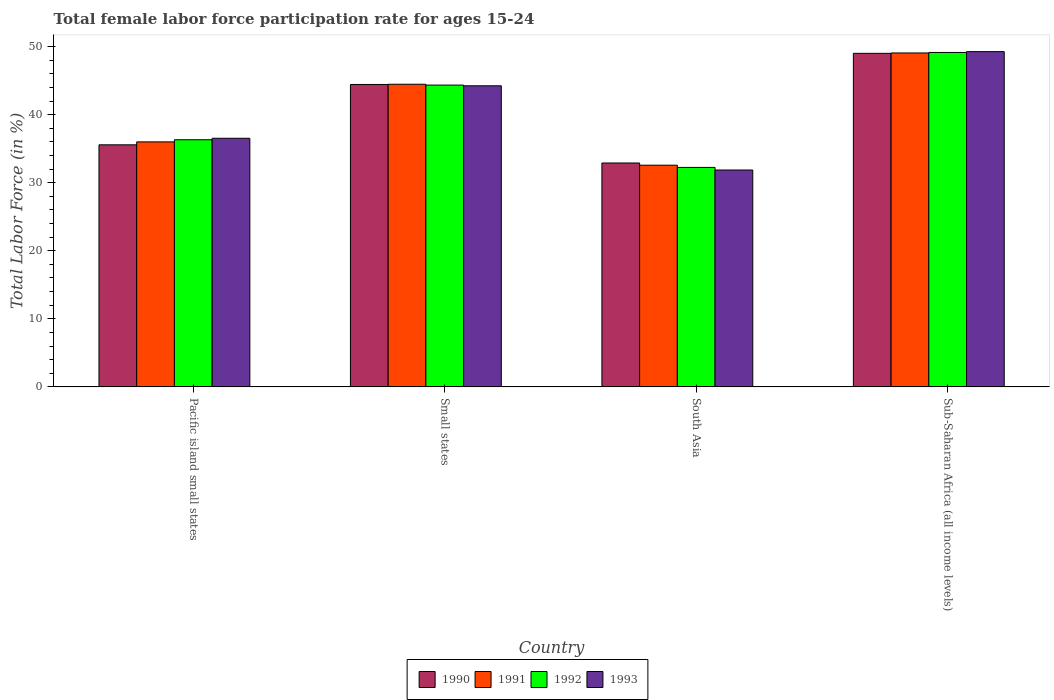Are the number of bars on each tick of the X-axis equal?
Your answer should be very brief. Yes. What is the label of the 1st group of bars from the left?
Your response must be concise. Pacific island small states. In how many cases, is the number of bars for a given country not equal to the number of legend labels?
Keep it short and to the point. 0. What is the female labor force participation rate in 1992 in South Asia?
Your answer should be very brief. 32.24. Across all countries, what is the maximum female labor force participation rate in 1993?
Give a very brief answer. 49.25. Across all countries, what is the minimum female labor force participation rate in 1992?
Give a very brief answer. 32.24. In which country was the female labor force participation rate in 1990 maximum?
Offer a terse response. Sub-Saharan Africa (all income levels). What is the total female labor force participation rate in 1993 in the graph?
Your answer should be very brief. 161.87. What is the difference between the female labor force participation rate in 1993 in Pacific island small states and that in Sub-Saharan Africa (all income levels)?
Offer a very short reply. -12.73. What is the difference between the female labor force participation rate in 1991 in South Asia and the female labor force participation rate in 1993 in Sub-Saharan Africa (all income levels)?
Your response must be concise. -16.68. What is the average female labor force participation rate in 1993 per country?
Provide a succinct answer. 40.47. What is the difference between the female labor force participation rate of/in 1991 and female labor force participation rate of/in 1990 in Small states?
Ensure brevity in your answer.  0.03. In how many countries, is the female labor force participation rate in 1993 greater than 36 %?
Ensure brevity in your answer.  3. What is the ratio of the female labor force participation rate in 1990 in Pacific island small states to that in Sub-Saharan Africa (all income levels)?
Provide a succinct answer. 0.73. What is the difference between the highest and the second highest female labor force participation rate in 1991?
Keep it short and to the point. 13.07. What is the difference between the highest and the lowest female labor force participation rate in 1991?
Your answer should be compact. 16.49. In how many countries, is the female labor force participation rate in 1992 greater than the average female labor force participation rate in 1992 taken over all countries?
Your answer should be very brief. 2. What does the 3rd bar from the right in Pacific island small states represents?
Keep it short and to the point. 1991. How many bars are there?
Provide a short and direct response. 16. Are all the bars in the graph horizontal?
Ensure brevity in your answer.  No. How many countries are there in the graph?
Your answer should be compact. 4. Are the values on the major ticks of Y-axis written in scientific E-notation?
Make the answer very short. No. Does the graph contain grids?
Offer a terse response. No. Where does the legend appear in the graph?
Provide a succinct answer. Bottom center. How many legend labels are there?
Offer a very short reply. 4. What is the title of the graph?
Provide a succinct answer. Total female labor force participation rate for ages 15-24. Does "1997" appear as one of the legend labels in the graph?
Your answer should be compact. No. What is the label or title of the X-axis?
Offer a very short reply. Country. What is the label or title of the Y-axis?
Offer a very short reply. Total Labor Force (in %). What is the Total Labor Force (in %) of 1990 in Pacific island small states?
Ensure brevity in your answer.  35.56. What is the Total Labor Force (in %) in 1991 in Pacific island small states?
Your answer should be very brief. 35.99. What is the Total Labor Force (in %) of 1992 in Pacific island small states?
Provide a short and direct response. 36.31. What is the Total Labor Force (in %) in 1993 in Pacific island small states?
Offer a very short reply. 36.52. What is the Total Labor Force (in %) of 1990 in Small states?
Provide a short and direct response. 44.43. What is the Total Labor Force (in %) of 1991 in Small states?
Make the answer very short. 44.46. What is the Total Labor Force (in %) of 1992 in Small states?
Offer a very short reply. 44.34. What is the Total Labor Force (in %) in 1993 in Small states?
Your answer should be compact. 44.24. What is the Total Labor Force (in %) of 1990 in South Asia?
Give a very brief answer. 32.89. What is the Total Labor Force (in %) of 1991 in South Asia?
Make the answer very short. 32.57. What is the Total Labor Force (in %) of 1992 in South Asia?
Offer a terse response. 32.24. What is the Total Labor Force (in %) in 1993 in South Asia?
Provide a short and direct response. 31.86. What is the Total Labor Force (in %) in 1990 in Sub-Saharan Africa (all income levels)?
Make the answer very short. 49. What is the Total Labor Force (in %) of 1991 in Sub-Saharan Africa (all income levels)?
Your answer should be very brief. 49.06. What is the Total Labor Force (in %) of 1992 in Sub-Saharan Africa (all income levels)?
Ensure brevity in your answer.  49.13. What is the Total Labor Force (in %) of 1993 in Sub-Saharan Africa (all income levels)?
Your response must be concise. 49.25. Across all countries, what is the maximum Total Labor Force (in %) in 1990?
Offer a terse response. 49. Across all countries, what is the maximum Total Labor Force (in %) of 1991?
Your answer should be compact. 49.06. Across all countries, what is the maximum Total Labor Force (in %) of 1992?
Keep it short and to the point. 49.13. Across all countries, what is the maximum Total Labor Force (in %) of 1993?
Provide a succinct answer. 49.25. Across all countries, what is the minimum Total Labor Force (in %) of 1990?
Keep it short and to the point. 32.89. Across all countries, what is the minimum Total Labor Force (in %) of 1991?
Provide a succinct answer. 32.57. Across all countries, what is the minimum Total Labor Force (in %) in 1992?
Your answer should be compact. 32.24. Across all countries, what is the minimum Total Labor Force (in %) in 1993?
Ensure brevity in your answer.  31.86. What is the total Total Labor Force (in %) of 1990 in the graph?
Offer a terse response. 161.89. What is the total Total Labor Force (in %) of 1991 in the graph?
Give a very brief answer. 162.08. What is the total Total Labor Force (in %) in 1992 in the graph?
Ensure brevity in your answer.  162.02. What is the total Total Labor Force (in %) of 1993 in the graph?
Give a very brief answer. 161.87. What is the difference between the Total Labor Force (in %) of 1990 in Pacific island small states and that in Small states?
Your response must be concise. -8.87. What is the difference between the Total Labor Force (in %) in 1991 in Pacific island small states and that in Small states?
Provide a short and direct response. -8.47. What is the difference between the Total Labor Force (in %) in 1992 in Pacific island small states and that in Small states?
Your answer should be compact. -8.03. What is the difference between the Total Labor Force (in %) in 1993 in Pacific island small states and that in Small states?
Your response must be concise. -7.71. What is the difference between the Total Labor Force (in %) of 1990 in Pacific island small states and that in South Asia?
Ensure brevity in your answer.  2.67. What is the difference between the Total Labor Force (in %) in 1991 in Pacific island small states and that in South Asia?
Keep it short and to the point. 3.43. What is the difference between the Total Labor Force (in %) in 1992 in Pacific island small states and that in South Asia?
Provide a succinct answer. 4.06. What is the difference between the Total Labor Force (in %) in 1993 in Pacific island small states and that in South Asia?
Keep it short and to the point. 4.66. What is the difference between the Total Labor Force (in %) in 1990 in Pacific island small states and that in Sub-Saharan Africa (all income levels)?
Keep it short and to the point. -13.44. What is the difference between the Total Labor Force (in %) in 1991 in Pacific island small states and that in Sub-Saharan Africa (all income levels)?
Your response must be concise. -13.07. What is the difference between the Total Labor Force (in %) in 1992 in Pacific island small states and that in Sub-Saharan Africa (all income levels)?
Ensure brevity in your answer.  -12.82. What is the difference between the Total Labor Force (in %) of 1993 in Pacific island small states and that in Sub-Saharan Africa (all income levels)?
Your answer should be very brief. -12.73. What is the difference between the Total Labor Force (in %) of 1990 in Small states and that in South Asia?
Your answer should be very brief. 11.54. What is the difference between the Total Labor Force (in %) in 1991 in Small states and that in South Asia?
Provide a short and direct response. 11.89. What is the difference between the Total Labor Force (in %) in 1992 in Small states and that in South Asia?
Your answer should be compact. 12.1. What is the difference between the Total Labor Force (in %) of 1993 in Small states and that in South Asia?
Offer a terse response. 12.37. What is the difference between the Total Labor Force (in %) in 1990 in Small states and that in Sub-Saharan Africa (all income levels)?
Provide a short and direct response. -4.57. What is the difference between the Total Labor Force (in %) in 1991 in Small states and that in Sub-Saharan Africa (all income levels)?
Keep it short and to the point. -4.6. What is the difference between the Total Labor Force (in %) of 1992 in Small states and that in Sub-Saharan Africa (all income levels)?
Provide a short and direct response. -4.79. What is the difference between the Total Labor Force (in %) in 1993 in Small states and that in Sub-Saharan Africa (all income levels)?
Your response must be concise. -5.02. What is the difference between the Total Labor Force (in %) in 1990 in South Asia and that in Sub-Saharan Africa (all income levels)?
Make the answer very short. -16.11. What is the difference between the Total Labor Force (in %) in 1991 in South Asia and that in Sub-Saharan Africa (all income levels)?
Provide a short and direct response. -16.49. What is the difference between the Total Labor Force (in %) in 1992 in South Asia and that in Sub-Saharan Africa (all income levels)?
Your answer should be compact. -16.89. What is the difference between the Total Labor Force (in %) in 1993 in South Asia and that in Sub-Saharan Africa (all income levels)?
Your response must be concise. -17.39. What is the difference between the Total Labor Force (in %) in 1990 in Pacific island small states and the Total Labor Force (in %) in 1991 in Small states?
Provide a succinct answer. -8.9. What is the difference between the Total Labor Force (in %) in 1990 in Pacific island small states and the Total Labor Force (in %) in 1992 in Small states?
Your answer should be very brief. -8.78. What is the difference between the Total Labor Force (in %) in 1990 in Pacific island small states and the Total Labor Force (in %) in 1993 in Small states?
Give a very brief answer. -8.67. What is the difference between the Total Labor Force (in %) in 1991 in Pacific island small states and the Total Labor Force (in %) in 1992 in Small states?
Offer a very short reply. -8.35. What is the difference between the Total Labor Force (in %) in 1991 in Pacific island small states and the Total Labor Force (in %) in 1993 in Small states?
Your answer should be compact. -8.24. What is the difference between the Total Labor Force (in %) in 1992 in Pacific island small states and the Total Labor Force (in %) in 1993 in Small states?
Provide a succinct answer. -7.93. What is the difference between the Total Labor Force (in %) in 1990 in Pacific island small states and the Total Labor Force (in %) in 1991 in South Asia?
Ensure brevity in your answer.  2.99. What is the difference between the Total Labor Force (in %) of 1990 in Pacific island small states and the Total Labor Force (in %) of 1992 in South Asia?
Provide a succinct answer. 3.32. What is the difference between the Total Labor Force (in %) of 1990 in Pacific island small states and the Total Labor Force (in %) of 1993 in South Asia?
Provide a succinct answer. 3.7. What is the difference between the Total Labor Force (in %) in 1991 in Pacific island small states and the Total Labor Force (in %) in 1992 in South Asia?
Your answer should be very brief. 3.75. What is the difference between the Total Labor Force (in %) in 1991 in Pacific island small states and the Total Labor Force (in %) in 1993 in South Asia?
Provide a short and direct response. 4.13. What is the difference between the Total Labor Force (in %) in 1992 in Pacific island small states and the Total Labor Force (in %) in 1993 in South Asia?
Keep it short and to the point. 4.45. What is the difference between the Total Labor Force (in %) of 1990 in Pacific island small states and the Total Labor Force (in %) of 1991 in Sub-Saharan Africa (all income levels)?
Your answer should be very brief. -13.5. What is the difference between the Total Labor Force (in %) of 1990 in Pacific island small states and the Total Labor Force (in %) of 1992 in Sub-Saharan Africa (all income levels)?
Provide a succinct answer. -13.57. What is the difference between the Total Labor Force (in %) of 1990 in Pacific island small states and the Total Labor Force (in %) of 1993 in Sub-Saharan Africa (all income levels)?
Make the answer very short. -13.69. What is the difference between the Total Labor Force (in %) in 1991 in Pacific island small states and the Total Labor Force (in %) in 1992 in Sub-Saharan Africa (all income levels)?
Your answer should be compact. -13.14. What is the difference between the Total Labor Force (in %) in 1991 in Pacific island small states and the Total Labor Force (in %) in 1993 in Sub-Saharan Africa (all income levels)?
Make the answer very short. -13.26. What is the difference between the Total Labor Force (in %) of 1992 in Pacific island small states and the Total Labor Force (in %) of 1993 in Sub-Saharan Africa (all income levels)?
Provide a succinct answer. -12.95. What is the difference between the Total Labor Force (in %) of 1990 in Small states and the Total Labor Force (in %) of 1991 in South Asia?
Give a very brief answer. 11.86. What is the difference between the Total Labor Force (in %) in 1990 in Small states and the Total Labor Force (in %) in 1992 in South Asia?
Provide a short and direct response. 12.19. What is the difference between the Total Labor Force (in %) of 1990 in Small states and the Total Labor Force (in %) of 1993 in South Asia?
Give a very brief answer. 12.57. What is the difference between the Total Labor Force (in %) in 1991 in Small states and the Total Labor Force (in %) in 1992 in South Asia?
Your response must be concise. 12.22. What is the difference between the Total Labor Force (in %) of 1991 in Small states and the Total Labor Force (in %) of 1993 in South Asia?
Offer a very short reply. 12.6. What is the difference between the Total Labor Force (in %) of 1992 in Small states and the Total Labor Force (in %) of 1993 in South Asia?
Provide a succinct answer. 12.48. What is the difference between the Total Labor Force (in %) of 1990 in Small states and the Total Labor Force (in %) of 1991 in Sub-Saharan Africa (all income levels)?
Your answer should be compact. -4.63. What is the difference between the Total Labor Force (in %) in 1990 in Small states and the Total Labor Force (in %) in 1992 in Sub-Saharan Africa (all income levels)?
Offer a terse response. -4.7. What is the difference between the Total Labor Force (in %) in 1990 in Small states and the Total Labor Force (in %) in 1993 in Sub-Saharan Africa (all income levels)?
Your response must be concise. -4.82. What is the difference between the Total Labor Force (in %) of 1991 in Small states and the Total Labor Force (in %) of 1992 in Sub-Saharan Africa (all income levels)?
Offer a terse response. -4.67. What is the difference between the Total Labor Force (in %) of 1991 in Small states and the Total Labor Force (in %) of 1993 in Sub-Saharan Africa (all income levels)?
Your answer should be very brief. -4.79. What is the difference between the Total Labor Force (in %) of 1992 in Small states and the Total Labor Force (in %) of 1993 in Sub-Saharan Africa (all income levels)?
Provide a short and direct response. -4.91. What is the difference between the Total Labor Force (in %) in 1990 in South Asia and the Total Labor Force (in %) in 1991 in Sub-Saharan Africa (all income levels)?
Offer a very short reply. -16.17. What is the difference between the Total Labor Force (in %) of 1990 in South Asia and the Total Labor Force (in %) of 1992 in Sub-Saharan Africa (all income levels)?
Provide a succinct answer. -16.24. What is the difference between the Total Labor Force (in %) in 1990 in South Asia and the Total Labor Force (in %) in 1993 in Sub-Saharan Africa (all income levels)?
Offer a terse response. -16.36. What is the difference between the Total Labor Force (in %) in 1991 in South Asia and the Total Labor Force (in %) in 1992 in Sub-Saharan Africa (all income levels)?
Offer a very short reply. -16.56. What is the difference between the Total Labor Force (in %) in 1991 in South Asia and the Total Labor Force (in %) in 1993 in Sub-Saharan Africa (all income levels)?
Your answer should be very brief. -16.68. What is the difference between the Total Labor Force (in %) of 1992 in South Asia and the Total Labor Force (in %) of 1993 in Sub-Saharan Africa (all income levels)?
Provide a short and direct response. -17.01. What is the average Total Labor Force (in %) of 1990 per country?
Provide a succinct answer. 40.47. What is the average Total Labor Force (in %) of 1991 per country?
Your answer should be very brief. 40.52. What is the average Total Labor Force (in %) of 1992 per country?
Keep it short and to the point. 40.51. What is the average Total Labor Force (in %) in 1993 per country?
Give a very brief answer. 40.47. What is the difference between the Total Labor Force (in %) of 1990 and Total Labor Force (in %) of 1991 in Pacific island small states?
Your answer should be compact. -0.43. What is the difference between the Total Labor Force (in %) of 1990 and Total Labor Force (in %) of 1992 in Pacific island small states?
Make the answer very short. -0.75. What is the difference between the Total Labor Force (in %) of 1990 and Total Labor Force (in %) of 1993 in Pacific island small states?
Provide a short and direct response. -0.96. What is the difference between the Total Labor Force (in %) of 1991 and Total Labor Force (in %) of 1992 in Pacific island small states?
Provide a short and direct response. -0.31. What is the difference between the Total Labor Force (in %) of 1991 and Total Labor Force (in %) of 1993 in Pacific island small states?
Give a very brief answer. -0.53. What is the difference between the Total Labor Force (in %) in 1992 and Total Labor Force (in %) in 1993 in Pacific island small states?
Keep it short and to the point. -0.22. What is the difference between the Total Labor Force (in %) of 1990 and Total Labor Force (in %) of 1991 in Small states?
Your answer should be very brief. -0.03. What is the difference between the Total Labor Force (in %) of 1990 and Total Labor Force (in %) of 1992 in Small states?
Give a very brief answer. 0.09. What is the difference between the Total Labor Force (in %) in 1990 and Total Labor Force (in %) in 1993 in Small states?
Give a very brief answer. 0.19. What is the difference between the Total Labor Force (in %) in 1991 and Total Labor Force (in %) in 1992 in Small states?
Provide a succinct answer. 0.12. What is the difference between the Total Labor Force (in %) in 1991 and Total Labor Force (in %) in 1993 in Small states?
Offer a very short reply. 0.22. What is the difference between the Total Labor Force (in %) in 1992 and Total Labor Force (in %) in 1993 in Small states?
Ensure brevity in your answer.  0.1. What is the difference between the Total Labor Force (in %) of 1990 and Total Labor Force (in %) of 1991 in South Asia?
Give a very brief answer. 0.32. What is the difference between the Total Labor Force (in %) of 1990 and Total Labor Force (in %) of 1992 in South Asia?
Keep it short and to the point. 0.65. What is the difference between the Total Labor Force (in %) in 1990 and Total Labor Force (in %) in 1993 in South Asia?
Keep it short and to the point. 1.03. What is the difference between the Total Labor Force (in %) in 1991 and Total Labor Force (in %) in 1992 in South Asia?
Your response must be concise. 0.32. What is the difference between the Total Labor Force (in %) in 1991 and Total Labor Force (in %) in 1993 in South Asia?
Offer a very short reply. 0.71. What is the difference between the Total Labor Force (in %) of 1992 and Total Labor Force (in %) of 1993 in South Asia?
Offer a terse response. 0.38. What is the difference between the Total Labor Force (in %) of 1990 and Total Labor Force (in %) of 1991 in Sub-Saharan Africa (all income levels)?
Offer a very short reply. -0.06. What is the difference between the Total Labor Force (in %) in 1990 and Total Labor Force (in %) in 1992 in Sub-Saharan Africa (all income levels)?
Offer a terse response. -0.13. What is the difference between the Total Labor Force (in %) of 1990 and Total Labor Force (in %) of 1993 in Sub-Saharan Africa (all income levels)?
Your answer should be very brief. -0.25. What is the difference between the Total Labor Force (in %) in 1991 and Total Labor Force (in %) in 1992 in Sub-Saharan Africa (all income levels)?
Give a very brief answer. -0.07. What is the difference between the Total Labor Force (in %) in 1991 and Total Labor Force (in %) in 1993 in Sub-Saharan Africa (all income levels)?
Keep it short and to the point. -0.19. What is the difference between the Total Labor Force (in %) in 1992 and Total Labor Force (in %) in 1993 in Sub-Saharan Africa (all income levels)?
Give a very brief answer. -0.12. What is the ratio of the Total Labor Force (in %) in 1990 in Pacific island small states to that in Small states?
Your response must be concise. 0.8. What is the ratio of the Total Labor Force (in %) in 1991 in Pacific island small states to that in Small states?
Provide a succinct answer. 0.81. What is the ratio of the Total Labor Force (in %) of 1992 in Pacific island small states to that in Small states?
Make the answer very short. 0.82. What is the ratio of the Total Labor Force (in %) in 1993 in Pacific island small states to that in Small states?
Ensure brevity in your answer.  0.83. What is the ratio of the Total Labor Force (in %) of 1990 in Pacific island small states to that in South Asia?
Ensure brevity in your answer.  1.08. What is the ratio of the Total Labor Force (in %) of 1991 in Pacific island small states to that in South Asia?
Give a very brief answer. 1.11. What is the ratio of the Total Labor Force (in %) in 1992 in Pacific island small states to that in South Asia?
Provide a succinct answer. 1.13. What is the ratio of the Total Labor Force (in %) of 1993 in Pacific island small states to that in South Asia?
Give a very brief answer. 1.15. What is the ratio of the Total Labor Force (in %) of 1990 in Pacific island small states to that in Sub-Saharan Africa (all income levels)?
Your answer should be compact. 0.73. What is the ratio of the Total Labor Force (in %) in 1991 in Pacific island small states to that in Sub-Saharan Africa (all income levels)?
Offer a very short reply. 0.73. What is the ratio of the Total Labor Force (in %) in 1992 in Pacific island small states to that in Sub-Saharan Africa (all income levels)?
Provide a short and direct response. 0.74. What is the ratio of the Total Labor Force (in %) of 1993 in Pacific island small states to that in Sub-Saharan Africa (all income levels)?
Provide a short and direct response. 0.74. What is the ratio of the Total Labor Force (in %) in 1990 in Small states to that in South Asia?
Keep it short and to the point. 1.35. What is the ratio of the Total Labor Force (in %) in 1991 in Small states to that in South Asia?
Ensure brevity in your answer.  1.37. What is the ratio of the Total Labor Force (in %) of 1992 in Small states to that in South Asia?
Your answer should be very brief. 1.38. What is the ratio of the Total Labor Force (in %) of 1993 in Small states to that in South Asia?
Keep it short and to the point. 1.39. What is the ratio of the Total Labor Force (in %) of 1990 in Small states to that in Sub-Saharan Africa (all income levels)?
Ensure brevity in your answer.  0.91. What is the ratio of the Total Labor Force (in %) in 1991 in Small states to that in Sub-Saharan Africa (all income levels)?
Make the answer very short. 0.91. What is the ratio of the Total Labor Force (in %) in 1992 in Small states to that in Sub-Saharan Africa (all income levels)?
Offer a very short reply. 0.9. What is the ratio of the Total Labor Force (in %) in 1993 in Small states to that in Sub-Saharan Africa (all income levels)?
Offer a very short reply. 0.9. What is the ratio of the Total Labor Force (in %) of 1990 in South Asia to that in Sub-Saharan Africa (all income levels)?
Make the answer very short. 0.67. What is the ratio of the Total Labor Force (in %) of 1991 in South Asia to that in Sub-Saharan Africa (all income levels)?
Provide a succinct answer. 0.66. What is the ratio of the Total Labor Force (in %) of 1992 in South Asia to that in Sub-Saharan Africa (all income levels)?
Make the answer very short. 0.66. What is the ratio of the Total Labor Force (in %) in 1993 in South Asia to that in Sub-Saharan Africa (all income levels)?
Offer a terse response. 0.65. What is the difference between the highest and the second highest Total Labor Force (in %) in 1990?
Give a very brief answer. 4.57. What is the difference between the highest and the second highest Total Labor Force (in %) of 1991?
Provide a short and direct response. 4.6. What is the difference between the highest and the second highest Total Labor Force (in %) of 1992?
Give a very brief answer. 4.79. What is the difference between the highest and the second highest Total Labor Force (in %) of 1993?
Provide a succinct answer. 5.02. What is the difference between the highest and the lowest Total Labor Force (in %) of 1990?
Offer a terse response. 16.11. What is the difference between the highest and the lowest Total Labor Force (in %) of 1991?
Ensure brevity in your answer.  16.49. What is the difference between the highest and the lowest Total Labor Force (in %) of 1992?
Provide a succinct answer. 16.89. What is the difference between the highest and the lowest Total Labor Force (in %) in 1993?
Ensure brevity in your answer.  17.39. 